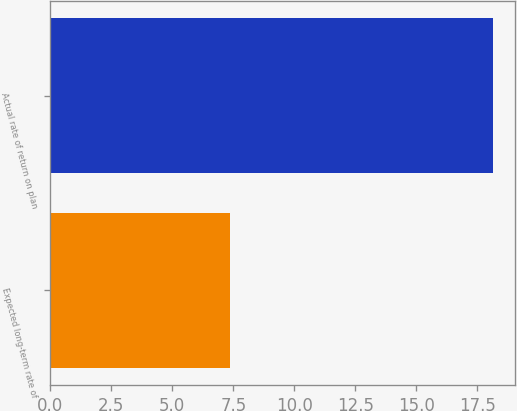Convert chart to OTSL. <chart><loc_0><loc_0><loc_500><loc_500><bar_chart><fcel>Expected long-term rate of<fcel>Actual rate of return on plan<nl><fcel>7.38<fcel>18.13<nl></chart> 